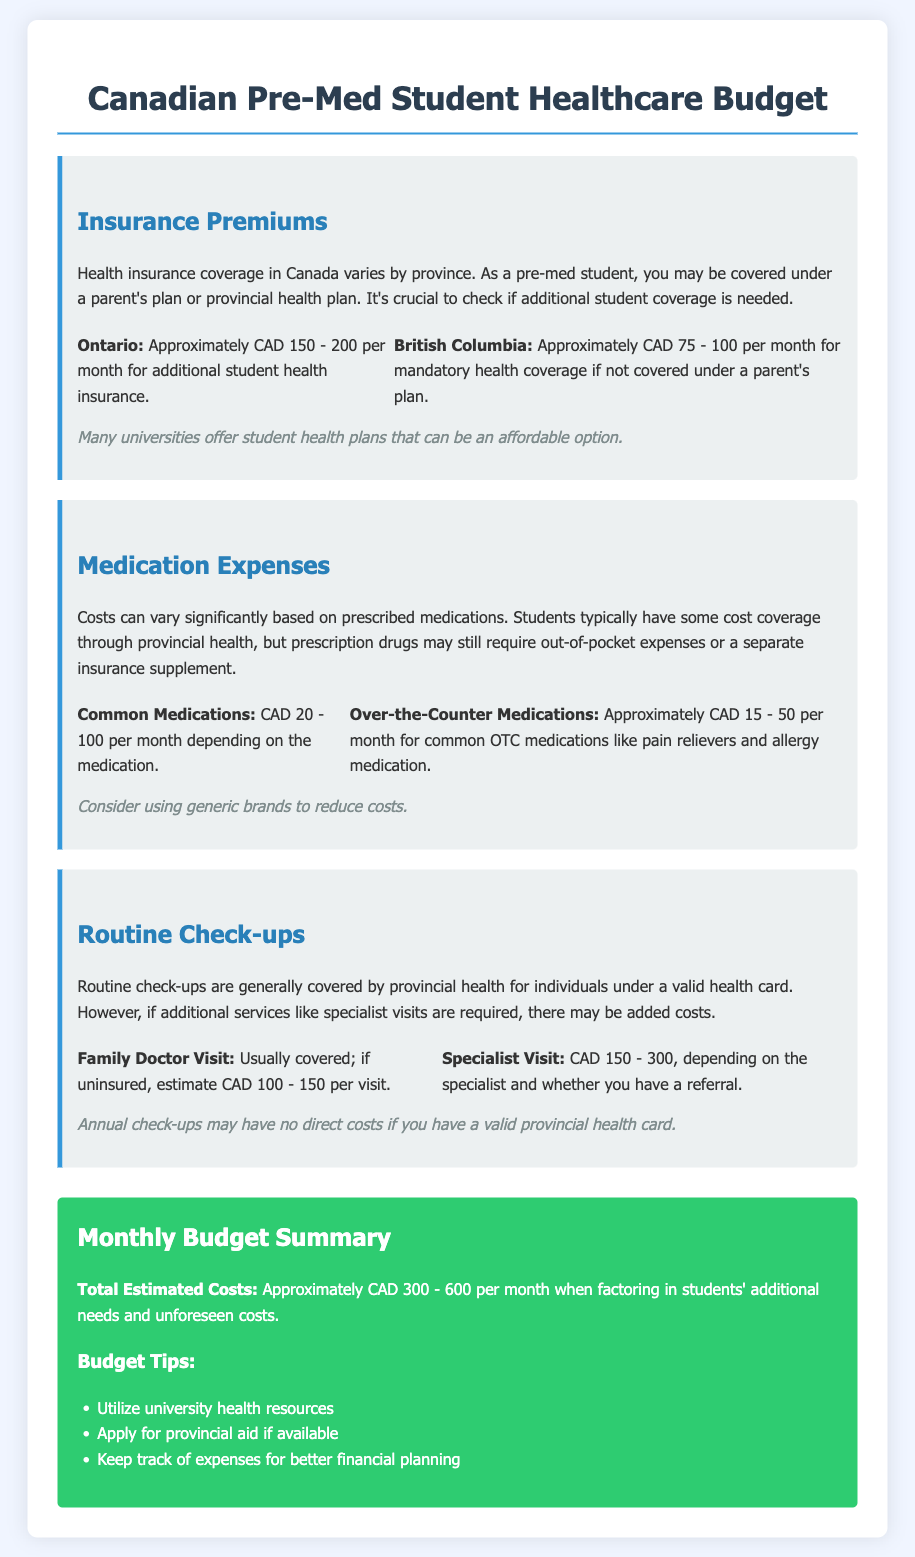what are the insurance premiums for Ontario? The document states that the insurance premiums for Ontario are approximately CAD 150 - 200 per month for additional student health insurance.
Answer: CAD 150 - 200 what is the estimated cost for common medications per month? The estimated cost for common medications ranges from CAD 20 - 100 per month depending on the medication.
Answer: CAD 20 - 100 what is the average cost for a family doctor visit if uninsured? If uninsured, the average cost for a family doctor visit is estimated to be CAD 100 - 150.
Answer: CAD 100 - 150 what can affect medication expenses? Prescription drugs may still require out-of-pocket expenses or a separate insurance supplement.
Answer: Out-of-pocket expenses what is the total estimated monthly budget range provided? The document provides a total estimated cost range of approximately CAD 300 - 600 per month when factoring in students' additional needs and unforeseen costs.
Answer: CAD 300 - 600 what should students do to keep healthcare costs low? The budget tips suggest utilizing university health resources and applying for provincial aid if available.
Answer: Utilize university health resources what is the cost of over-the-counter medications per month? The document estimates the cost of over-the-counter medications to be approximately CAD 15 - 50 per month.
Answer: CAD 15 - 50 what type of healthcare check-ups are covered by provincial health? Routine check-ups are generally covered by provincial health for individuals under a valid health card.
Answer: Routine check-ups how much is a specialist visit typically? A specialist visit typically costs CAD 150 - 300, depending on the specialist and whether you have a referral.
Answer: CAD 150 - 300 